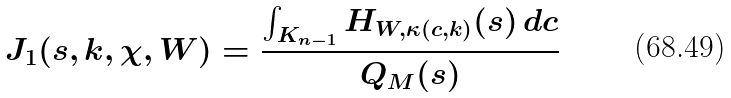Convert formula to latex. <formula><loc_0><loc_0><loc_500><loc_500>J _ { 1 } ( s , k , \chi , W ) = \frac { \int _ { K _ { n - 1 } } H _ { W , \kappa ( c , k ) } ( s ) \, d c } { Q _ { M } ( s ) }</formula> 